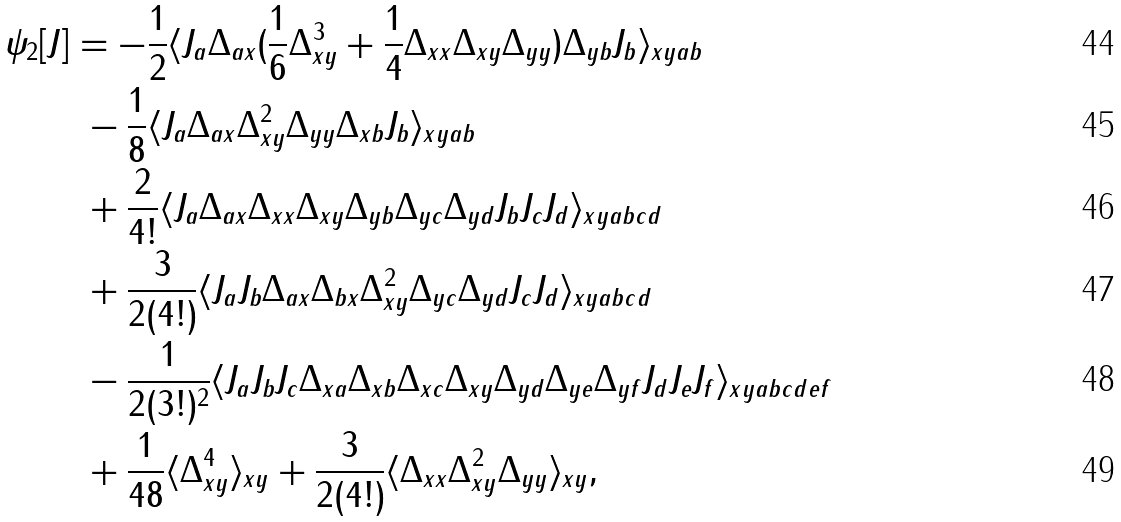<formula> <loc_0><loc_0><loc_500><loc_500>\psi _ { 2 } [ J ] & = - \frac { 1 } { 2 } \langle J _ { a } \Delta _ { a x } ( \frac { 1 } { 6 } \Delta _ { x y } ^ { 3 } + \frac { 1 } { 4 } \Delta _ { x x } \Delta _ { x y } \Delta _ { y y } ) \Delta _ { y b } J _ { b } \rangle _ { x y a b } \\ & \ - \frac { 1 } { 8 } \langle J _ { a } \Delta _ { a x } \Delta _ { x y } ^ { 2 } \Delta _ { y y } \Delta _ { x b } J _ { b } \rangle _ { x y a b } \\ & \ + \frac { 2 } { 4 ! } \langle J _ { a } \Delta _ { a x } \Delta _ { x x } \Delta _ { x y } \Delta _ { y b } \Delta _ { y c } \Delta _ { y d } J _ { b } J _ { c } J _ { d } \rangle _ { x y a b c d } \\ & \ + \frac { 3 } { 2 ( 4 ! ) } \langle J _ { a } J _ { b } \Delta _ { a x } \Delta _ { b x } \Delta _ { x y } ^ { 2 } \Delta _ { y c } \Delta _ { y d } J _ { c } J _ { d } \rangle _ { x y a b c d } \\ & \ - \frac { 1 } { 2 ( 3 ! ) ^ { 2 } } \langle J _ { a } J _ { b } J _ { c } \Delta _ { x a } \Delta _ { x b } \Delta _ { x c } \Delta _ { x y } \Delta _ { y d } \Delta _ { y e } \Delta _ { y f } J _ { d } J _ { e } J _ { f } \rangle _ { x y a b c d e f } \\ & \ + \frac { 1 } { 4 8 } \langle \Delta _ { x y } ^ { 4 } \rangle _ { x y } + \frac { 3 } { 2 ( 4 ! ) } \langle \Delta _ { x x } \Delta _ { x y } ^ { 2 } \Delta _ { y y } \rangle _ { x y } ,</formula> 